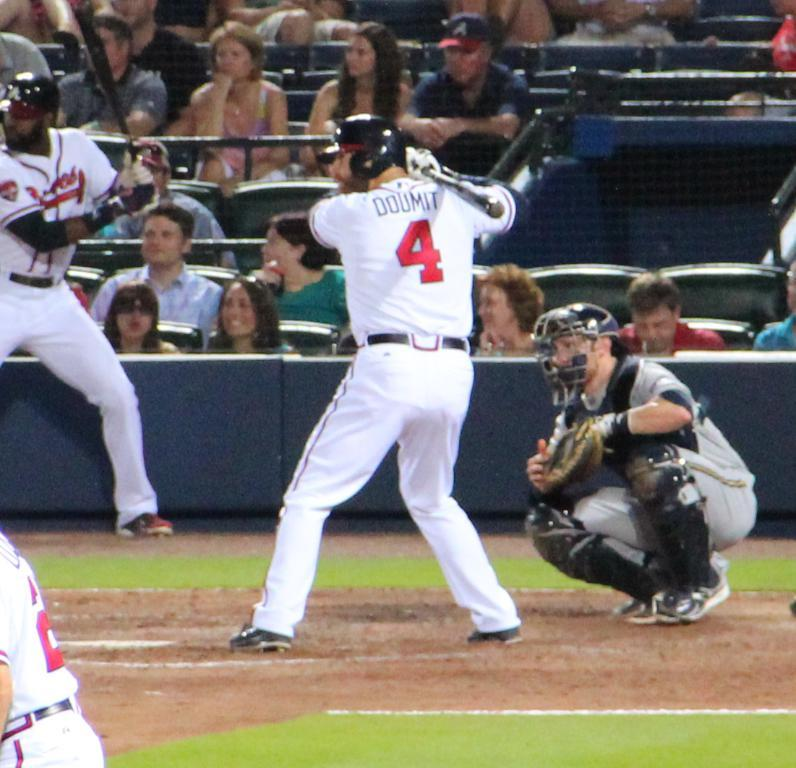<image>
Relay a brief, clear account of the picture shown. a person wearing the number 4 on their baseball jersey 